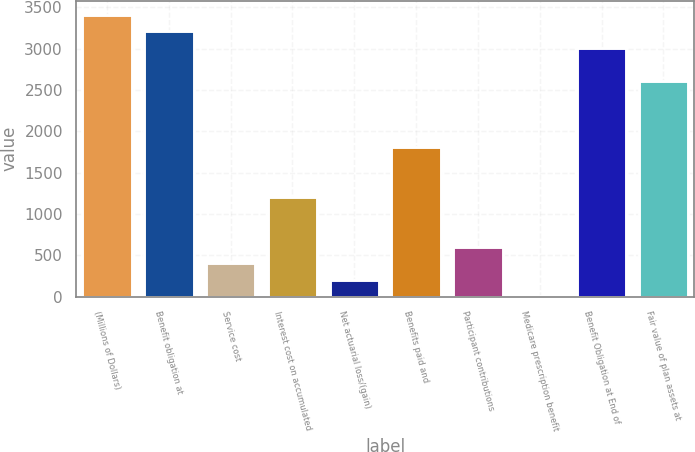Convert chart. <chart><loc_0><loc_0><loc_500><loc_500><bar_chart><fcel>(Millions of Dollars)<fcel>Benefit obligation at<fcel>Service cost<fcel>Interest cost on accumulated<fcel>Net actuarial loss/(gain)<fcel>Benefits paid and<fcel>Participant contributions<fcel>Medicare prescription benefit<fcel>Benefit Obligation at End of<fcel>Fair value of plan assets at<nl><fcel>3408.1<fcel>3207.8<fcel>403.6<fcel>1204.8<fcel>203.3<fcel>1805.7<fcel>603.9<fcel>3<fcel>3007.5<fcel>2606.9<nl></chart> 